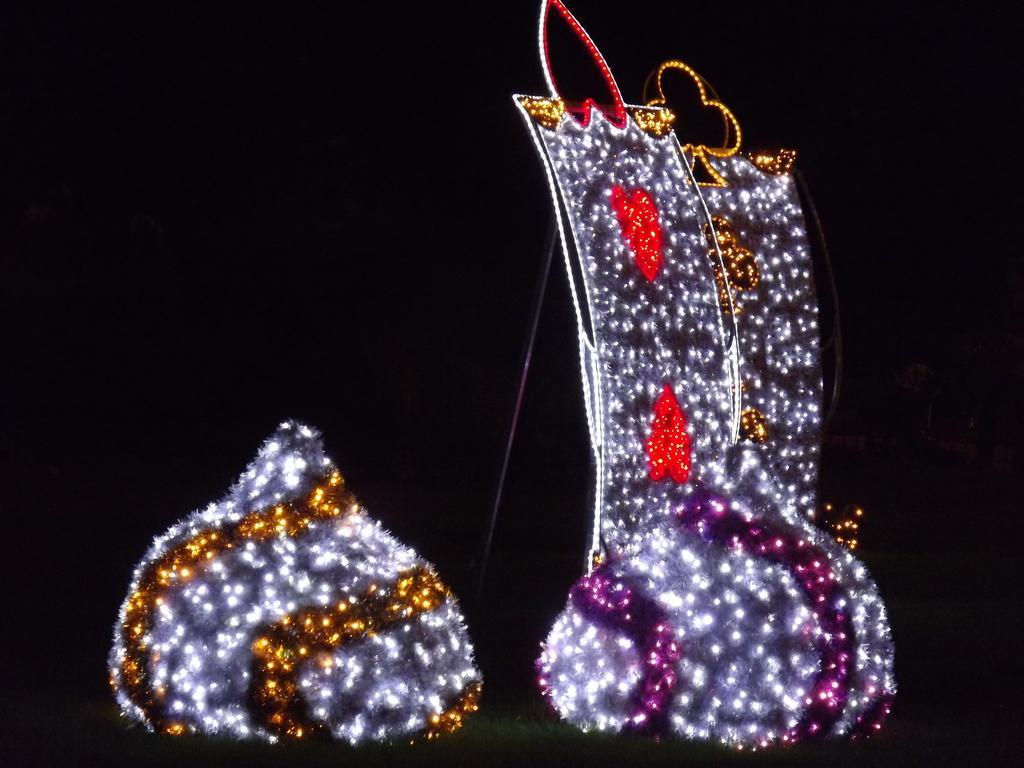Describe this image in one or two sentences. On the right side lights are arranged in different form, on the left side lights are arranged in a turnip shape. 